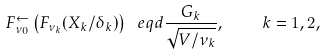Convert formula to latex. <formula><loc_0><loc_0><loc_500><loc_500>F _ { \nu _ { 0 } } ^ { \leftarrow } \left ( F _ { \nu _ { k } } ( X _ { k } / \delta _ { k } ) \right ) \ e q d \frac { G _ { k } } { \sqrt { V / \nu _ { k } } } , \quad k = 1 , 2 ,</formula> 